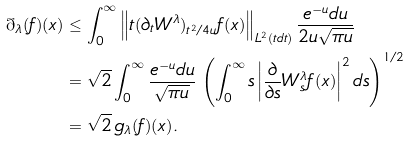Convert formula to latex. <formula><loc_0><loc_0><loc_500><loc_500>\mathbb { g } _ { \lambda } ( f ) ( x ) & \leq \int _ { 0 } ^ { \infty } \left \| t ( \partial _ { t } W ^ { \lambda } ) _ { t ^ { 2 } \slash 4 u } f ( x ) \right \| _ { L ^ { 2 } ( t d t ) } \frac { e ^ { - u } d u } { 2 u \sqrt { \pi u } } \\ & = \sqrt { 2 } \int _ { 0 } ^ { \infty } \frac { e ^ { - u } d u } { \sqrt { \pi u } } \, \left ( \int _ { 0 } ^ { \infty } s \left | \frac { \partial } { \partial s } W ^ { \lambda } _ { s } f ( x ) \right | ^ { 2 } d s \right ) ^ { 1 \slash 2 } \\ & = \sqrt { 2 } \, g _ { \lambda } ( f ) ( x ) .</formula> 